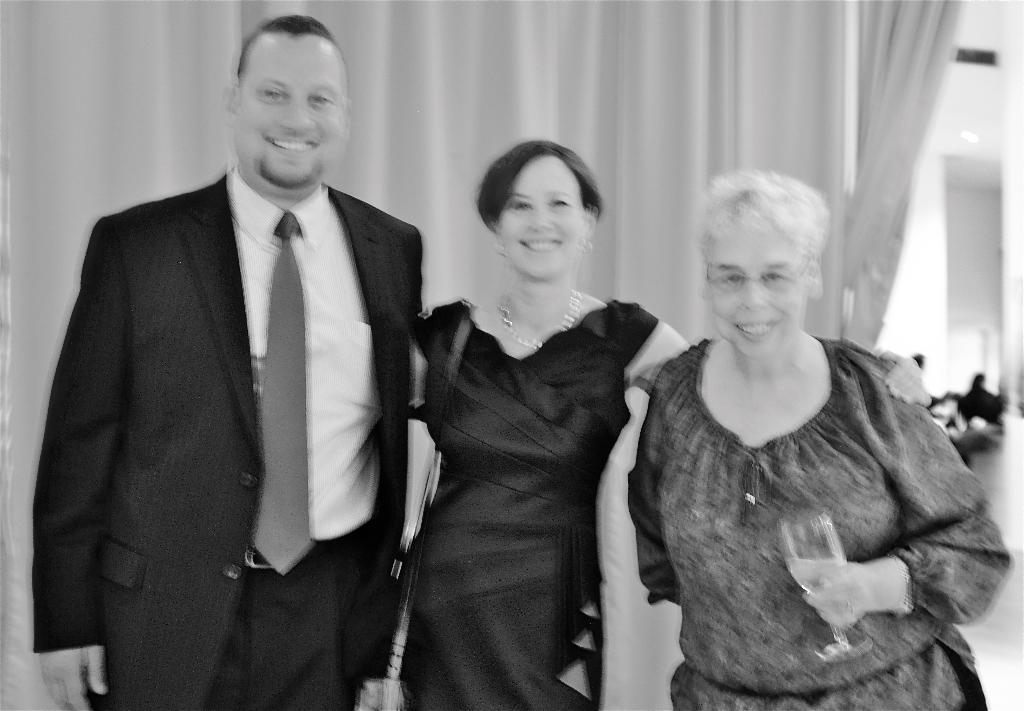How many people are in the foreground of the image? There are three persons in the foreground of the image. What can be seen in the background of the image? There is a curtain in the background of the image. What is visible on the right side of the image? There are people and a wall on the right side of the image. What type of bean is being used as a hat by one of the persons in the image? There is no bean present in the image, nor is any person wearing a bean as a hat. 